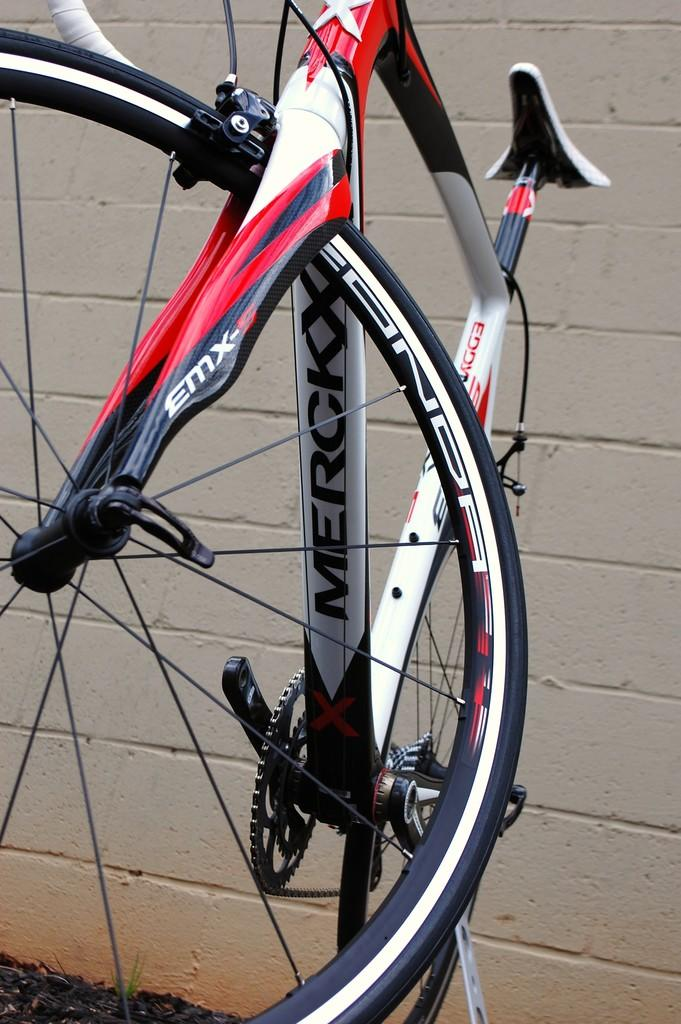What is the main subject of the picture? The main subject of the picture is a bicycle. What colors can be seen on the bicycle? The bicycle has red, black, and white colors. What is visible in the background of the picture? There is a wall in the background of the picture. Can you tell me how many horns are attached to the bicycle in the picture? There are no horns attached to the bicycle in the image. Is there a hat on the wall in the background of the picture? There is no hat visible on the wall in the background of the image. 